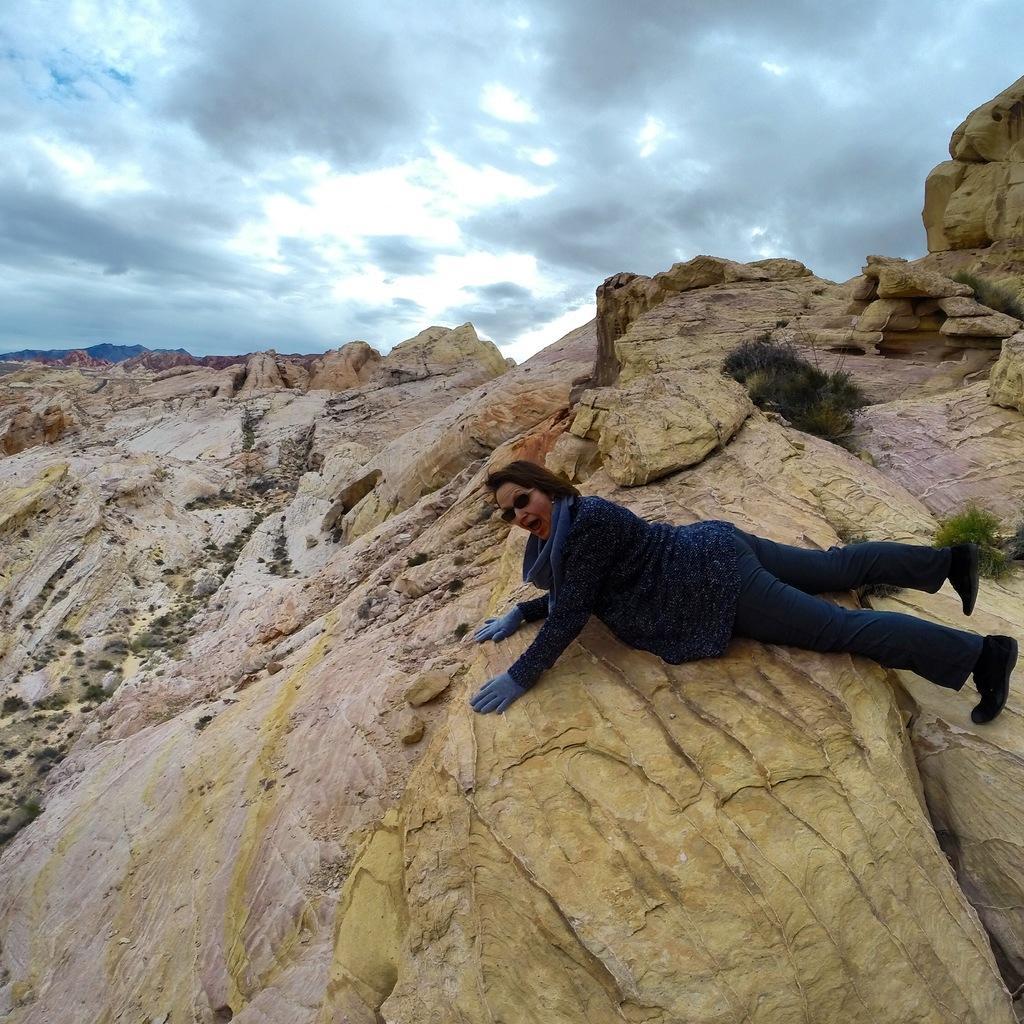Can you describe this image briefly? In the front of the image there is a rock surface, grass and person. At the top of the image there is a cloudy sky. 